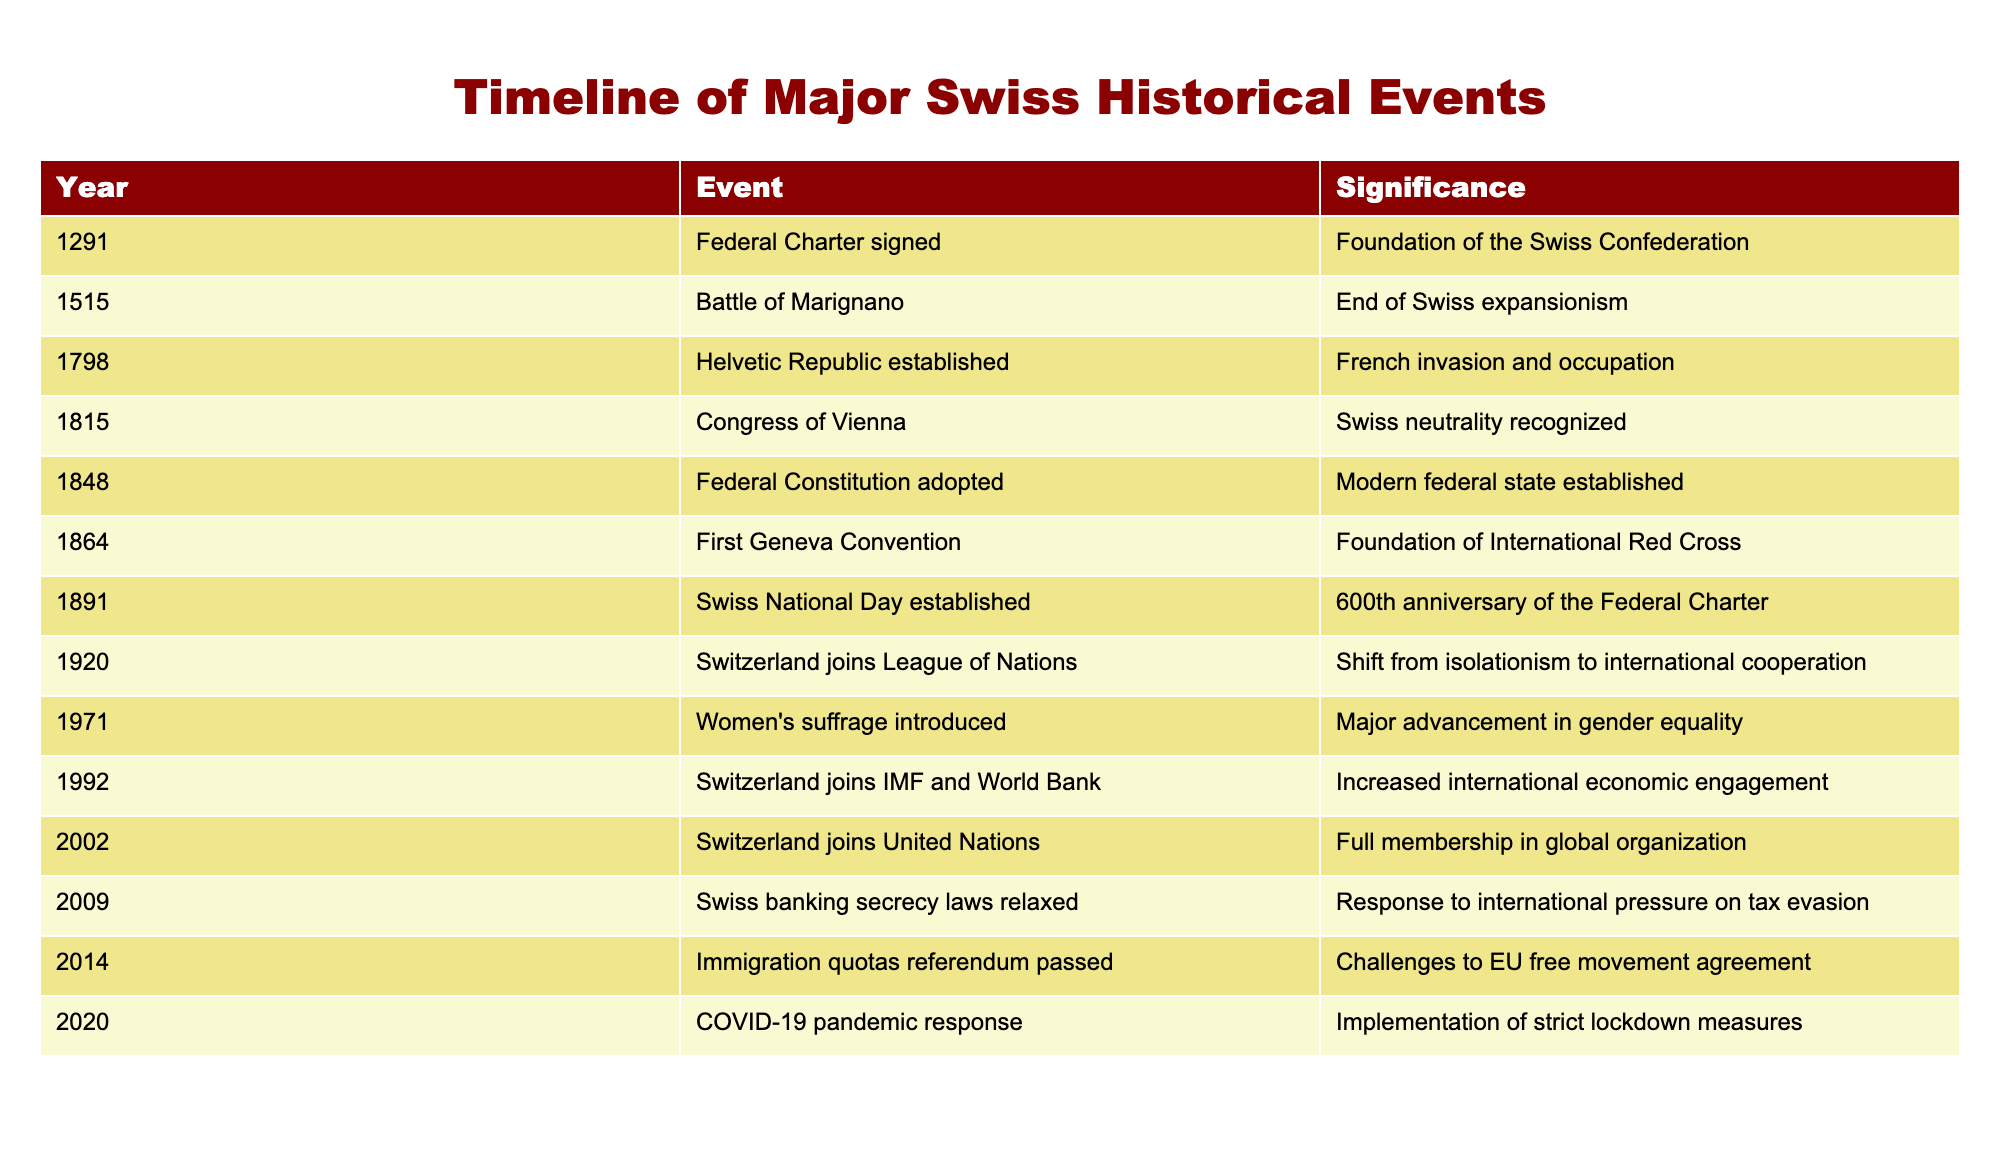What year was the Helvetic Republic established? According to the table, the Helvetic Republic was established in the year 1798.
Answer: 1798 What significant event occurred in 1815? The table states that in 1815, the Congress of Vienna took place, recognizing Swiss neutrality.
Answer: Congress of Vienna Was women's suffrage introduced in Switzerland before or after 1971? The table shows that women's suffrage was introduced in Switzerland in 1971, so it was introduced in 1971.
Answer: 1971 Which event marks the end of Swiss expansionism? The table lists the Battle of Marignano in 1515 as the event marking the end of Swiss expansionism.
Answer: Battle of Marignano What is the difference in years between the establishment of the Federal Constitution and Switzerland joining the United Nations? The Federal Constitution was adopted in 1848 and Switzerland joined the United Nations in 2002. The years difference is 2002 - 1848 = 154 years.
Answer: 154 years Did Switzerland join the League of Nations before or after it became a federal state? The Federal Constitution was adopted in 1848, and Switzerland joined the League of Nations in 1920. Therefore, Switzerland joined the League of Nations after becoming a federal state.
Answer: After What were the two major events in the 20th century related to international organizations? The table shows Switzerland joining the League of Nations in 1920 and joining the IMF and World Bank in 1992 as two major events related to international organizations.
Answer: League of Nations in 1920 and IMF & World Bank in 1992 How many years passed between the establishment of the first Geneva Convention and Switzerland joining the United Nations? The first Geneva Convention was established in 1864 and Switzerland became a UN member in 2002. The number of years between them is 2002 - 1864 = 138 years.
Answer: 138 years Was the federal charter signed before or after the establishment of the Swiss National Day? The federal charter was signed in 1291 and the Swiss National Day was established in 1891. Since 1291 is earlier than 1891, the federal charter was signed before the establishment of the Swiss National Day.
Answer: Before 